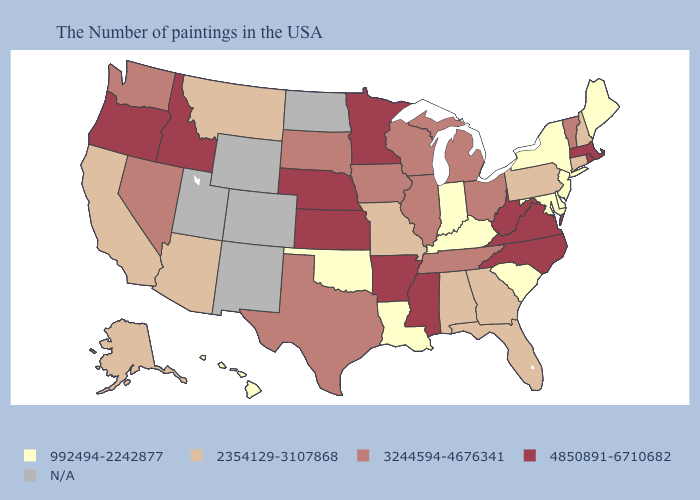Among the states that border Nebraska , does Iowa have the lowest value?
Give a very brief answer. No. Does New Jersey have the lowest value in the Northeast?
Short answer required. Yes. Name the states that have a value in the range 2354129-3107868?
Give a very brief answer. New Hampshire, Connecticut, Pennsylvania, Florida, Georgia, Alabama, Missouri, Montana, Arizona, California, Alaska. Name the states that have a value in the range N/A?
Concise answer only. North Dakota, Wyoming, Colorado, New Mexico, Utah. Among the states that border Wyoming , does South Dakota have the lowest value?
Keep it brief. No. Does the map have missing data?
Quick response, please. Yes. What is the highest value in states that border New Jersey?
Short answer required. 2354129-3107868. Name the states that have a value in the range 2354129-3107868?
Quick response, please. New Hampshire, Connecticut, Pennsylvania, Florida, Georgia, Alabama, Missouri, Montana, Arizona, California, Alaska. Does Arkansas have the highest value in the South?
Quick response, please. Yes. Among the states that border Alabama , does Mississippi have the lowest value?
Write a very short answer. No. What is the value of Arizona?
Quick response, please. 2354129-3107868. Which states hav the highest value in the Northeast?
Be succinct. Massachusetts, Rhode Island. What is the value of Tennessee?
Quick response, please. 3244594-4676341. Which states have the lowest value in the USA?
Quick response, please. Maine, New York, New Jersey, Delaware, Maryland, South Carolina, Kentucky, Indiana, Louisiana, Oklahoma, Hawaii. 